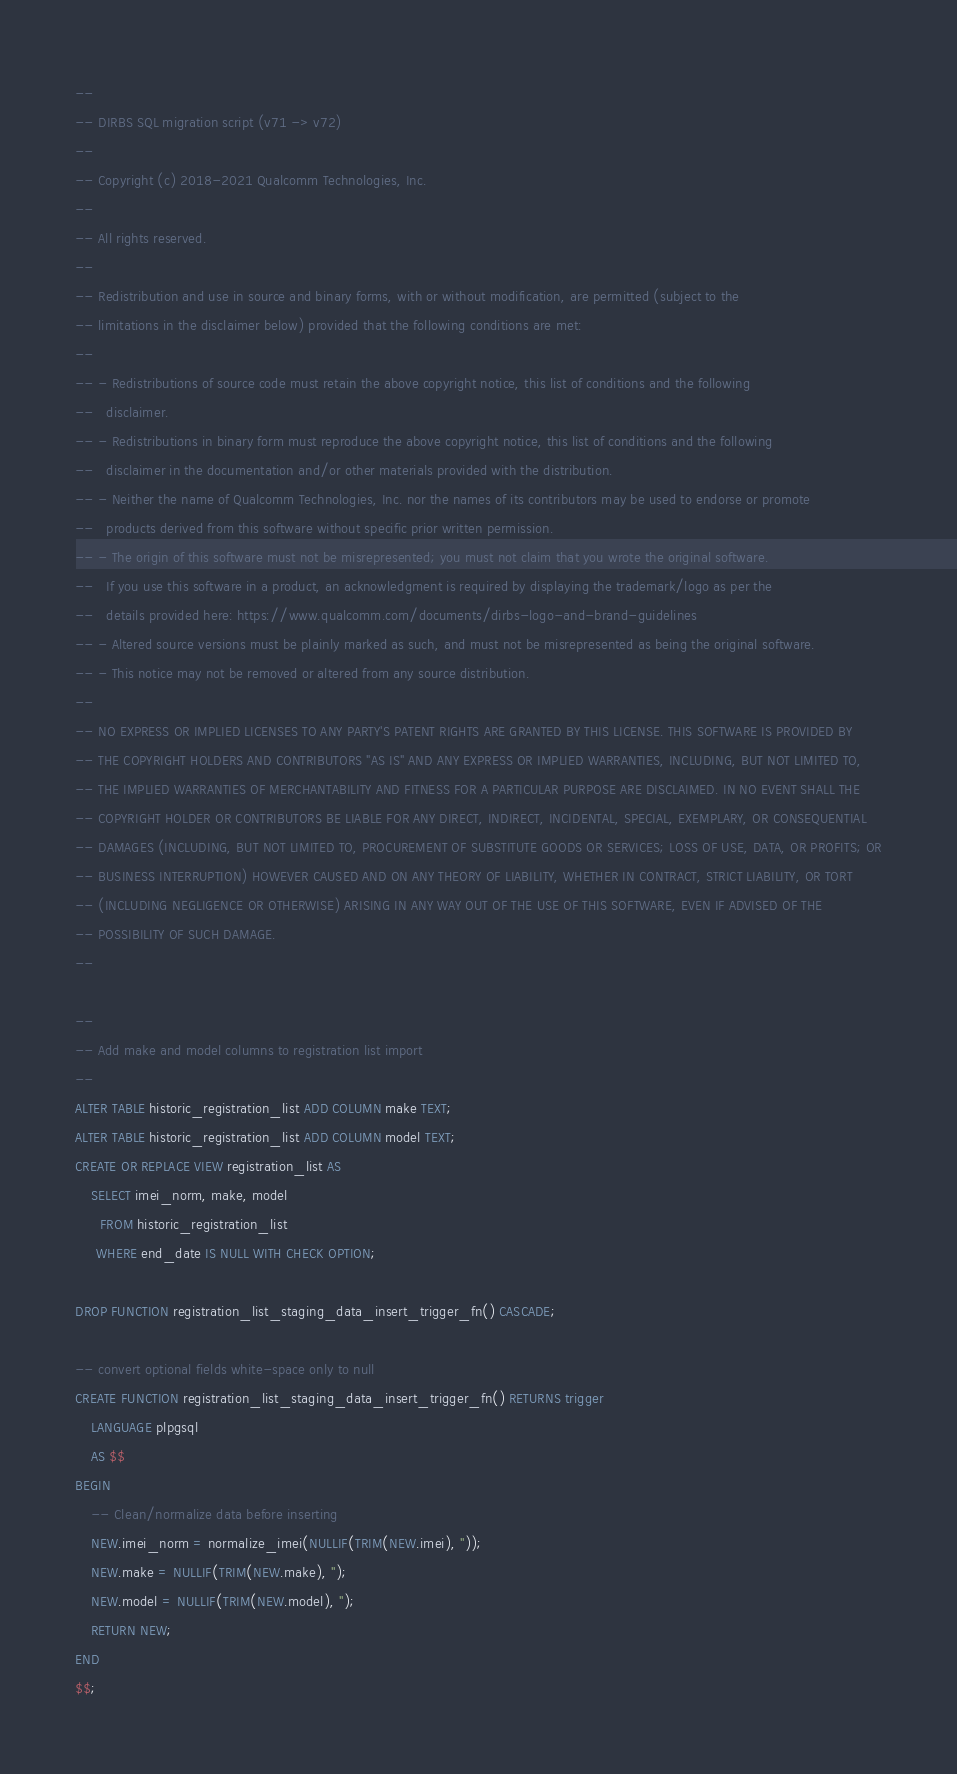<code> <loc_0><loc_0><loc_500><loc_500><_SQL_>--
-- DIRBS SQL migration script (v71 -> v72)
--
-- Copyright (c) 2018-2021 Qualcomm Technologies, Inc.
--
-- All rights reserved.
--
-- Redistribution and use in source and binary forms, with or without modification, are permitted (subject to the
-- limitations in the disclaimer below) provided that the following conditions are met:
--
-- - Redistributions of source code must retain the above copyright notice, this list of conditions and the following
--   disclaimer.
-- - Redistributions in binary form must reproduce the above copyright notice, this list of conditions and the following
--   disclaimer in the documentation and/or other materials provided with the distribution.
-- - Neither the name of Qualcomm Technologies, Inc. nor the names of its contributors may be used to endorse or promote
--   products derived from this software without specific prior written permission.
-- - The origin of this software must not be misrepresented; you must not claim that you wrote the original software.
--   If you use this software in a product, an acknowledgment is required by displaying the trademark/logo as per the
--   details provided here: https://www.qualcomm.com/documents/dirbs-logo-and-brand-guidelines
-- - Altered source versions must be plainly marked as such, and must not be misrepresented as being the original software.
-- - This notice may not be removed or altered from any source distribution.
--
-- NO EXPRESS OR IMPLIED LICENSES TO ANY PARTY'S PATENT RIGHTS ARE GRANTED BY THIS LICENSE. THIS SOFTWARE IS PROVIDED BY
-- THE COPYRIGHT HOLDERS AND CONTRIBUTORS "AS IS" AND ANY EXPRESS OR IMPLIED WARRANTIES, INCLUDING, BUT NOT LIMITED TO,
-- THE IMPLIED WARRANTIES OF MERCHANTABILITY AND FITNESS FOR A PARTICULAR PURPOSE ARE DISCLAIMED. IN NO EVENT SHALL THE
-- COPYRIGHT HOLDER OR CONTRIBUTORS BE LIABLE FOR ANY DIRECT, INDIRECT, INCIDENTAL, SPECIAL, EXEMPLARY, OR CONSEQUENTIAL
-- DAMAGES (INCLUDING, BUT NOT LIMITED TO, PROCUREMENT OF SUBSTITUTE GOODS OR SERVICES; LOSS OF USE, DATA, OR PROFITS; OR
-- BUSINESS INTERRUPTION) HOWEVER CAUSED AND ON ANY THEORY OF LIABILITY, WHETHER IN CONTRACT, STRICT LIABILITY, OR TORT
-- (INCLUDING NEGLIGENCE OR OTHERWISE) ARISING IN ANY WAY OUT OF THE USE OF THIS SOFTWARE, EVEN IF ADVISED OF THE
-- POSSIBILITY OF SUCH DAMAGE.
--

--
-- Add make and model columns to registration list import
--
ALTER TABLE historic_registration_list ADD COLUMN make TEXT;
ALTER TABLE historic_registration_list ADD COLUMN model TEXT;
CREATE OR REPLACE VIEW registration_list AS
    SELECT imei_norm, make, model
      FROM historic_registration_list
     WHERE end_date IS NULL WITH CHECK OPTION;

DROP FUNCTION registration_list_staging_data_insert_trigger_fn() CASCADE;

-- convert optional fields white-space only to null
CREATE FUNCTION registration_list_staging_data_insert_trigger_fn() RETURNS trigger
    LANGUAGE plpgsql
    AS $$
BEGIN
    -- Clean/normalize data before inserting
    NEW.imei_norm = normalize_imei(NULLIF(TRIM(NEW.imei), ''));
    NEW.make = NULLIF(TRIM(NEW.make), '');
    NEW.model = NULLIF(TRIM(NEW.model), '');
    RETURN NEW;
END
$$;
</code> 